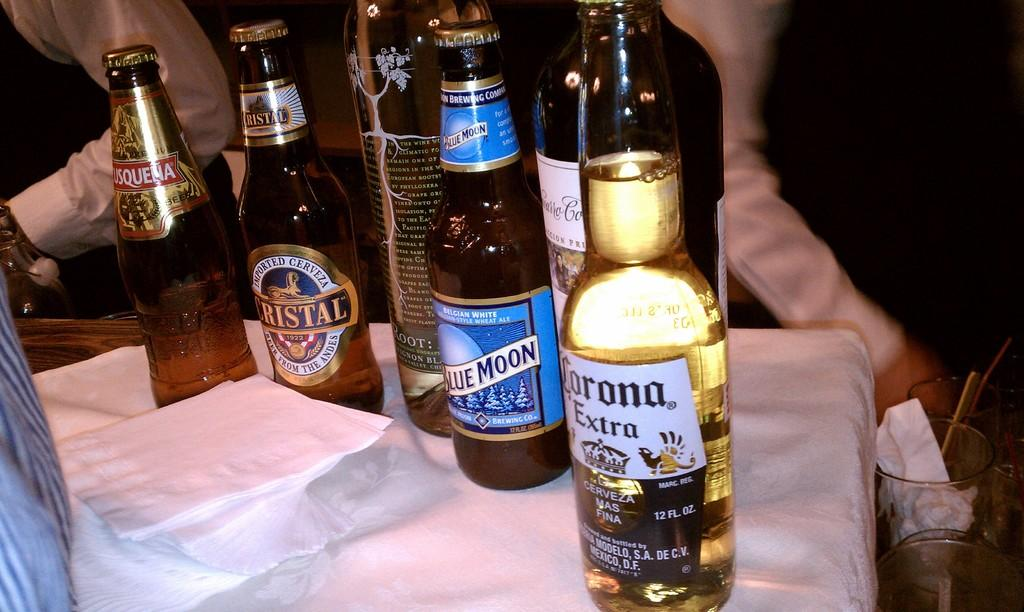<image>
Offer a succinct explanation of the picture presented. Multiple bottles of beer stand on a table including Corona Extra. 